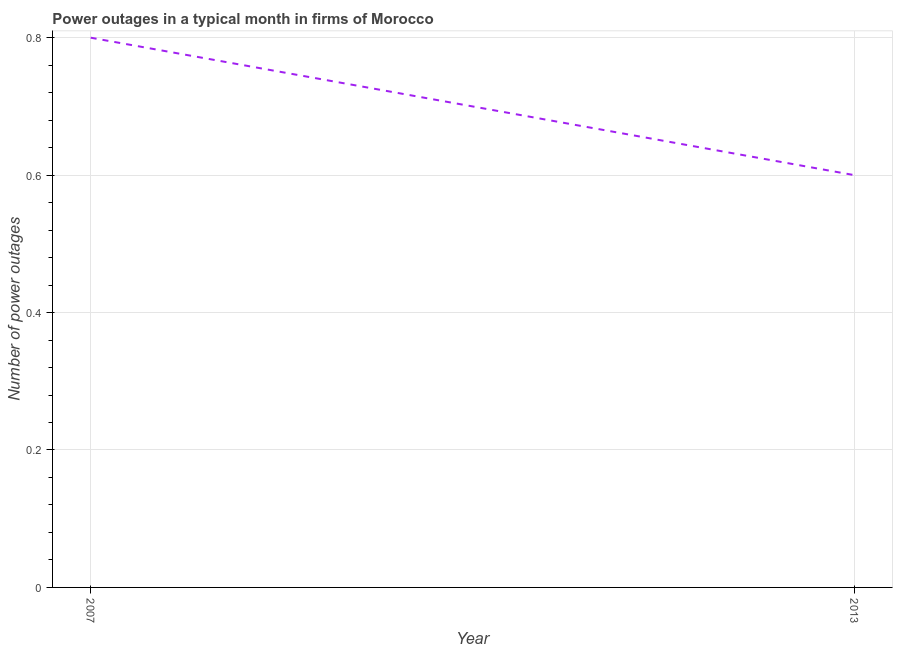What is the number of power outages in 2013?
Provide a succinct answer. 0.6. Across all years, what is the maximum number of power outages?
Offer a very short reply. 0.8. In which year was the number of power outages maximum?
Make the answer very short. 2007. In which year was the number of power outages minimum?
Your response must be concise. 2013. What is the sum of the number of power outages?
Your response must be concise. 1.4. What is the difference between the number of power outages in 2007 and 2013?
Provide a short and direct response. 0.2. What is the median number of power outages?
Provide a succinct answer. 0.7. What is the ratio of the number of power outages in 2007 to that in 2013?
Give a very brief answer. 1.33. Is the number of power outages in 2007 less than that in 2013?
Offer a terse response. No. Does the number of power outages monotonically increase over the years?
Your response must be concise. No. How many lines are there?
Provide a short and direct response. 1. What is the title of the graph?
Your response must be concise. Power outages in a typical month in firms of Morocco. What is the label or title of the Y-axis?
Offer a very short reply. Number of power outages. What is the Number of power outages in 2007?
Give a very brief answer. 0.8. What is the Number of power outages of 2013?
Provide a short and direct response. 0.6. What is the ratio of the Number of power outages in 2007 to that in 2013?
Your answer should be compact. 1.33. 